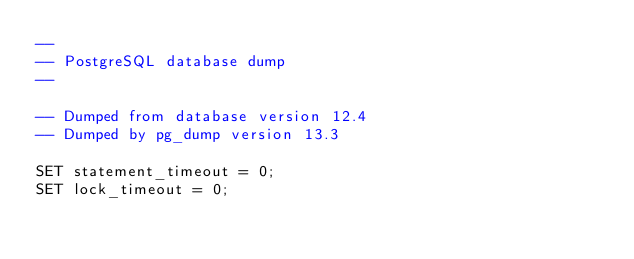Convert code to text. <code><loc_0><loc_0><loc_500><loc_500><_SQL_>--
-- PostgreSQL database dump
--

-- Dumped from database version 12.4
-- Dumped by pg_dump version 13.3

SET statement_timeout = 0;
SET lock_timeout = 0;</code> 